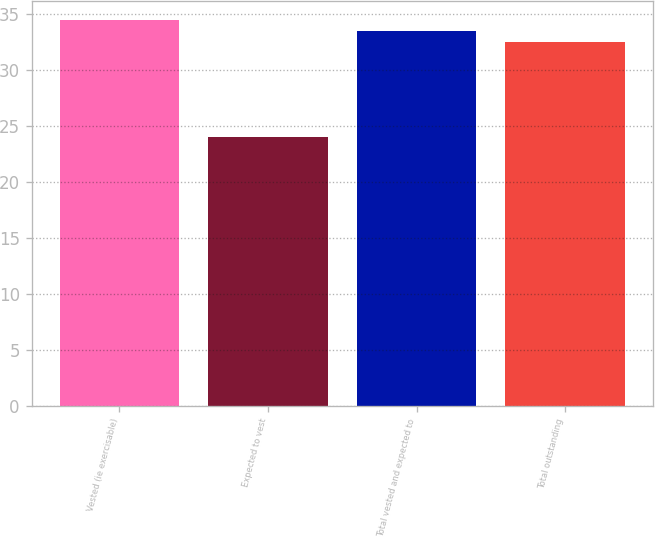Convert chart. <chart><loc_0><loc_0><loc_500><loc_500><bar_chart><fcel>Vested (ie exercisable)<fcel>Expected to vest<fcel>Total vested and expected to<fcel>Total outstanding<nl><fcel>34.49<fcel>24.01<fcel>33.5<fcel>32.51<nl></chart> 